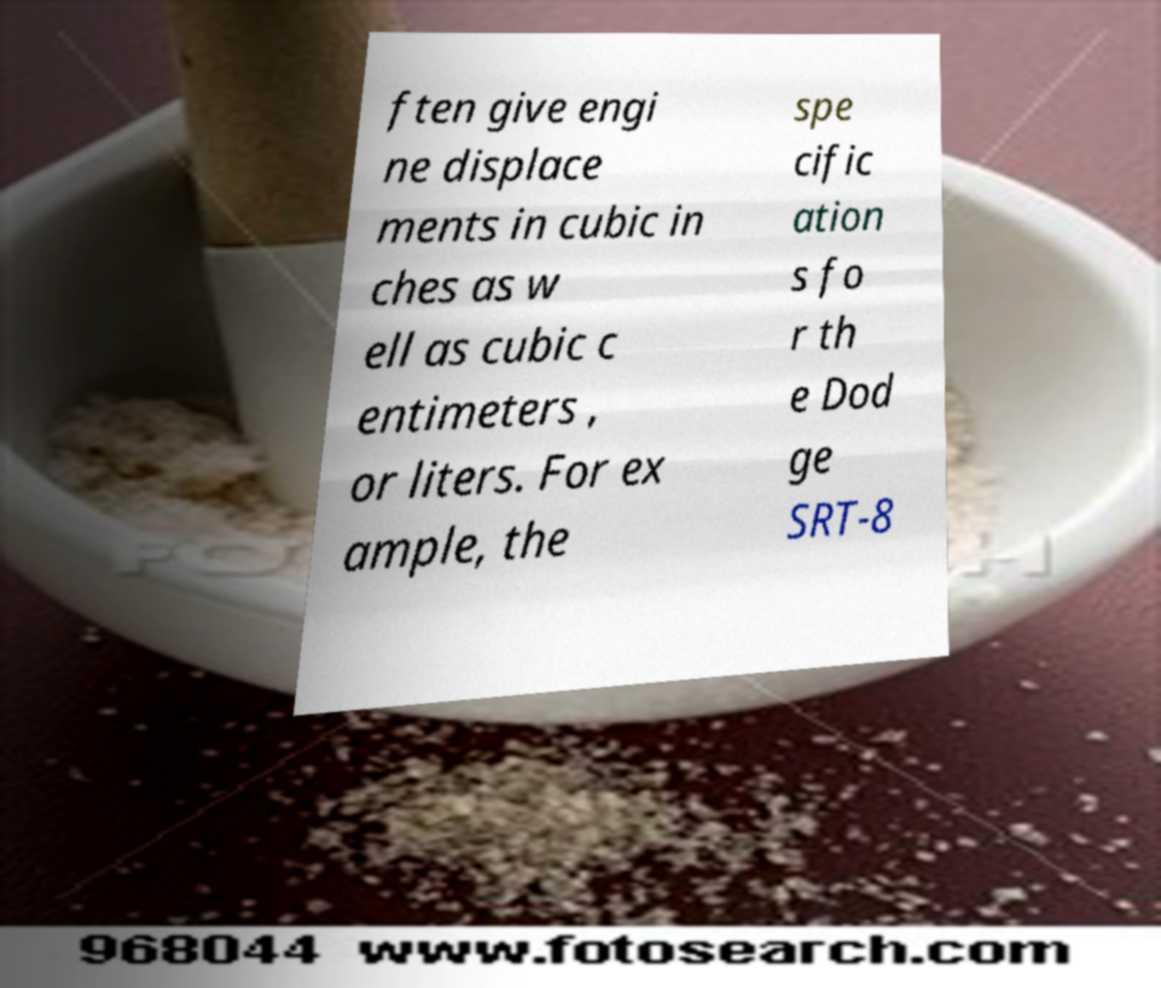There's text embedded in this image that I need extracted. Can you transcribe it verbatim? ften give engi ne displace ments in cubic in ches as w ell as cubic c entimeters , or liters. For ex ample, the spe cific ation s fo r th e Dod ge SRT-8 